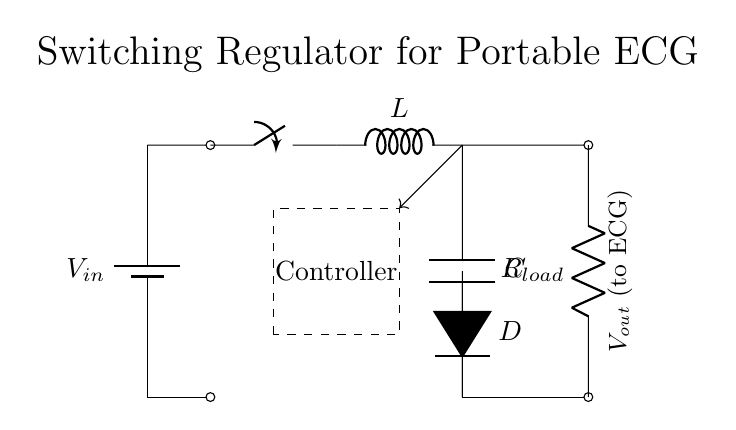What is the input voltage of this circuit? The circuit diagram shows a battery component labeled V_in at the input. As it is not specified in the diagram, the input voltage is merely referenced as V_in.
Answer: V_in What component is used for energy storage? The circuit includes a inductor presented with the label L, which is primarily responsible for energy storage in a switching regulator circuit.
Answer: L What is the load resistance in this circuit? The load resistance is represented by the component labeled R_load in the circuit diagram, which indicates the resistance connected to the output.
Answer: R_load What does the controller do in this circuit? The controller is indicated by the dashed rectangle, which regulates the operation of the switch to maintain the desired output voltage. This is essential in a switching regulator for feedback and stability.
Answer: Regulation What is the function of the diode in this circuit? The diode, labeled D, is used for rectification, allowing current to flow only in one direction to maintain consistent output voltage, preventing backflow into the inductor.
Answer: Rectification How is feedback achieved in this circuit? Feedback is indicated by the arrow pointing from the output (after the capacitor) to the controller, which ensures that the output voltage is monitored and compared to the desired value to adjust the switching action.
Answer: Monitoring What type of regulator is shown in the circuit? The circuit diagram depicts a switching regulator, as evidenced by the presence of the switch, inductor, and feedback mechanism, which distinguishes this type from linear regulators.
Answer: Switching 